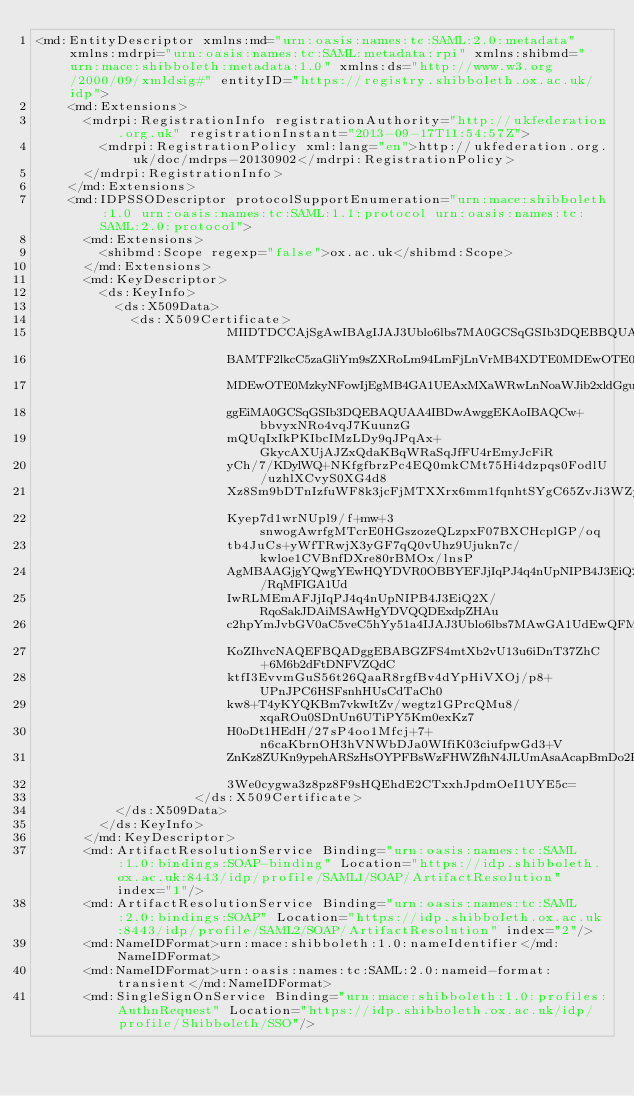Convert code to text. <code><loc_0><loc_0><loc_500><loc_500><_XML_><md:EntityDescriptor xmlns:md="urn:oasis:names:tc:SAML:2.0:metadata" xmlns:mdrpi="urn:oasis:names:tc:SAML:metadata:rpi" xmlns:shibmd="urn:mace:shibboleth:metadata:1.0" xmlns:ds="http://www.w3.org/2000/09/xmldsig#" entityID="https://registry.shibboleth.ox.ac.uk/idp">
    <md:Extensions>
      <mdrpi:RegistrationInfo registrationAuthority="http://ukfederation.org.uk" registrationInstant="2013-09-17T11:54:57Z">
        <mdrpi:RegistrationPolicy xml:lang="en">http://ukfederation.org.uk/doc/mdrps-20130902</mdrpi:RegistrationPolicy>
      </mdrpi:RegistrationInfo>
    </md:Extensions>
    <md:IDPSSODescriptor protocolSupportEnumeration="urn:mace:shibboleth:1.0 urn:oasis:names:tc:SAML:1.1:protocol urn:oasis:names:tc:SAML:2.0:protocol">
      <md:Extensions>
        <shibmd:Scope regexp="false">ox.ac.uk</shibmd:Scope>
      </md:Extensions>
      <md:KeyDescriptor>
        <ds:KeyInfo>
          <ds:X509Data>
            <ds:X509Certificate>
						MIIDTDCCAjSgAwIBAgIJAJ3Ublo6lbs7MA0GCSqGSIb3DQEBBQUAMCIxIDAeBgNV
						BAMTF2lkcC5zaGliYm9sZXRoLm94LmFjLnVrMB4XDTE0MDEwOTE0MzkyNFoXDTM0
						MDEwOTE0MzkyNFowIjEgMB4GA1UEAxMXaWRwLnNoaWJib2xldGgub3guYWMudWsw
						ggEiMA0GCSqGSIb3DQEBAQUAA4IBDwAwggEKAoIBAQCw+bbvyxNRo4vqJ7KuunzG
						mQUqIxIkPKIbcIMzLDy9qJPqAx+GkycAXUjAJZxQdaKBqWRaSqJfFU4rEmyJcFiR
						yCh/7/KDylWQ+NKfgfbrzPc4EQ0mkCMt75Hi4dzpqs0FodlU/uzhlXCvyS0XG4d8
						Xz8Sm9bDTnIzfuWF8k3jcFjMTXXrx6mm1fqnhtSYgC65ZvJi3WZySF1KjAcWfg4p
						Kyep7d1wrNUpl9/f+mw+3snwogAwrfgMTcrE0HGszozeQLzpxF07BXCHcplGP/oq
						tb4JuCs+yWfTRwjX3yGF7qQ0vUhz9Ujukn7c/kwloe1CVBnfDXre80rBMOx/lnsP
						AgMBAAGjgYQwgYEwHQYDVR0OBBYEFJjIqPJ4q4nUpNIPB4J3EiQ2X/RqMFIGA1Ud
						IwRLMEmAFJjIqPJ4q4nUpNIPB4J3EiQ2X/RqoSakJDAiMSAwHgYDVQQDExdpZHAu
						c2hpYmJvbGV0aC5veC5hYy51a4IJAJ3Ublo6lbs7MAwGA1UdEwQFMAMBAf8wDQYJ
						KoZIhvcNAQEFBQADggEBABGZFS4mtXb2vU13u6iDnT37ZhC+6M6b2dFtDNFVZQdC
						ktfI3EvvmGuS56t26QaaR8rgfBv4dYpHiVXOj/p8+UPnJPC6HSFsnhHUsCdTaCh0
						kw8+T4yKYQKBm7vkwItZv/wegtz1GPrcQMu8/xqaROu0SDnUn6UTiPY5Km0exKz7
						H0oDt1HEdH/27sP4oo1Mfcj+7+n6caKbrnOH3hVNWbDJa0WIfiK03ciufpwGd3+V
						ZnKz8ZUKn9ypehARSzHsOYPFBsWzFHWZfhN4JLUmAsaAcapBmDo2Rn1ZkXDAGYMT
						3We0cygwa3z8pz8F9sHQEhdE2CTxxhJpdmOeI1UYE5c=
					</ds:X509Certificate>
          </ds:X509Data>
        </ds:KeyInfo>
      </md:KeyDescriptor>
      <md:ArtifactResolutionService Binding="urn:oasis:names:tc:SAML:1.0:bindings:SOAP-binding" Location="https://idp.shibboleth.ox.ac.uk:8443/idp/profile/SAML1/SOAP/ArtifactResolution" index="1"/>
      <md:ArtifactResolutionService Binding="urn:oasis:names:tc:SAML:2.0:bindings:SOAP" Location="https://idp.shibboleth.ox.ac.uk:8443/idp/profile/SAML2/SOAP/ArtifactResolution" index="2"/>
      <md:NameIDFormat>urn:mace:shibboleth:1.0:nameIdentifier</md:NameIDFormat>
      <md:NameIDFormat>urn:oasis:names:tc:SAML:2.0:nameid-format:transient</md:NameIDFormat>
      <md:SingleSignOnService Binding="urn:mace:shibboleth:1.0:profiles:AuthnRequest" Location="https://idp.shibboleth.ox.ac.uk/idp/profile/Shibboleth/SSO"/></code> 